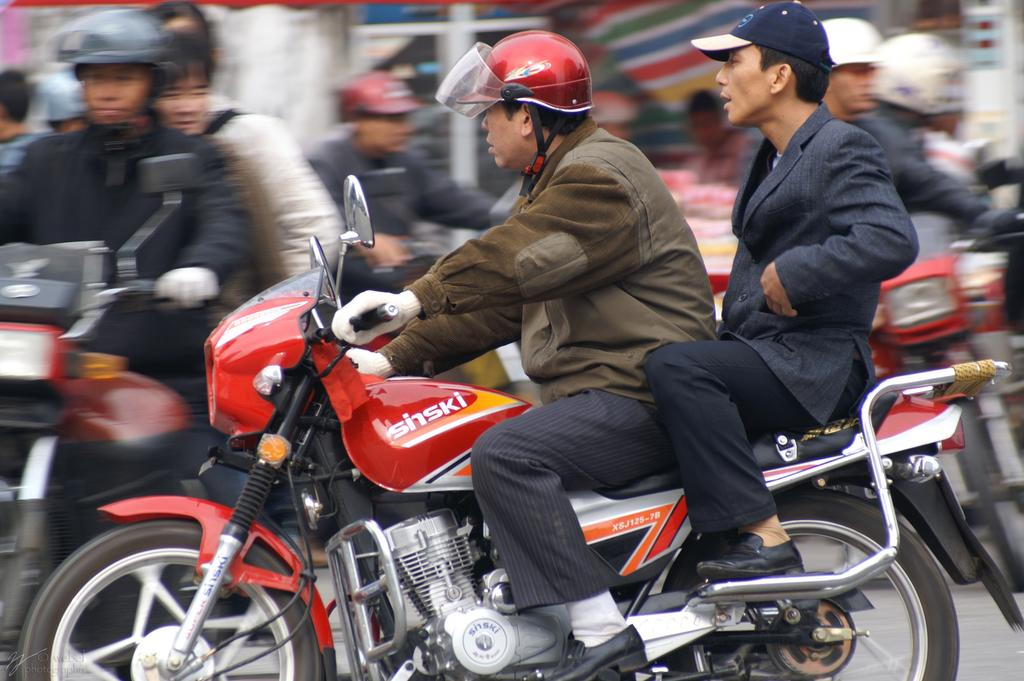How many people are riding a bike in the image? There are two persons riding a bike in the image. Where is the bike located? The bike is on a road. Can you describe the background activity in the image? There is a group of persons riding bikes in the background of the image. What type of oven can be seen in the image? There is no oven present in the image. 